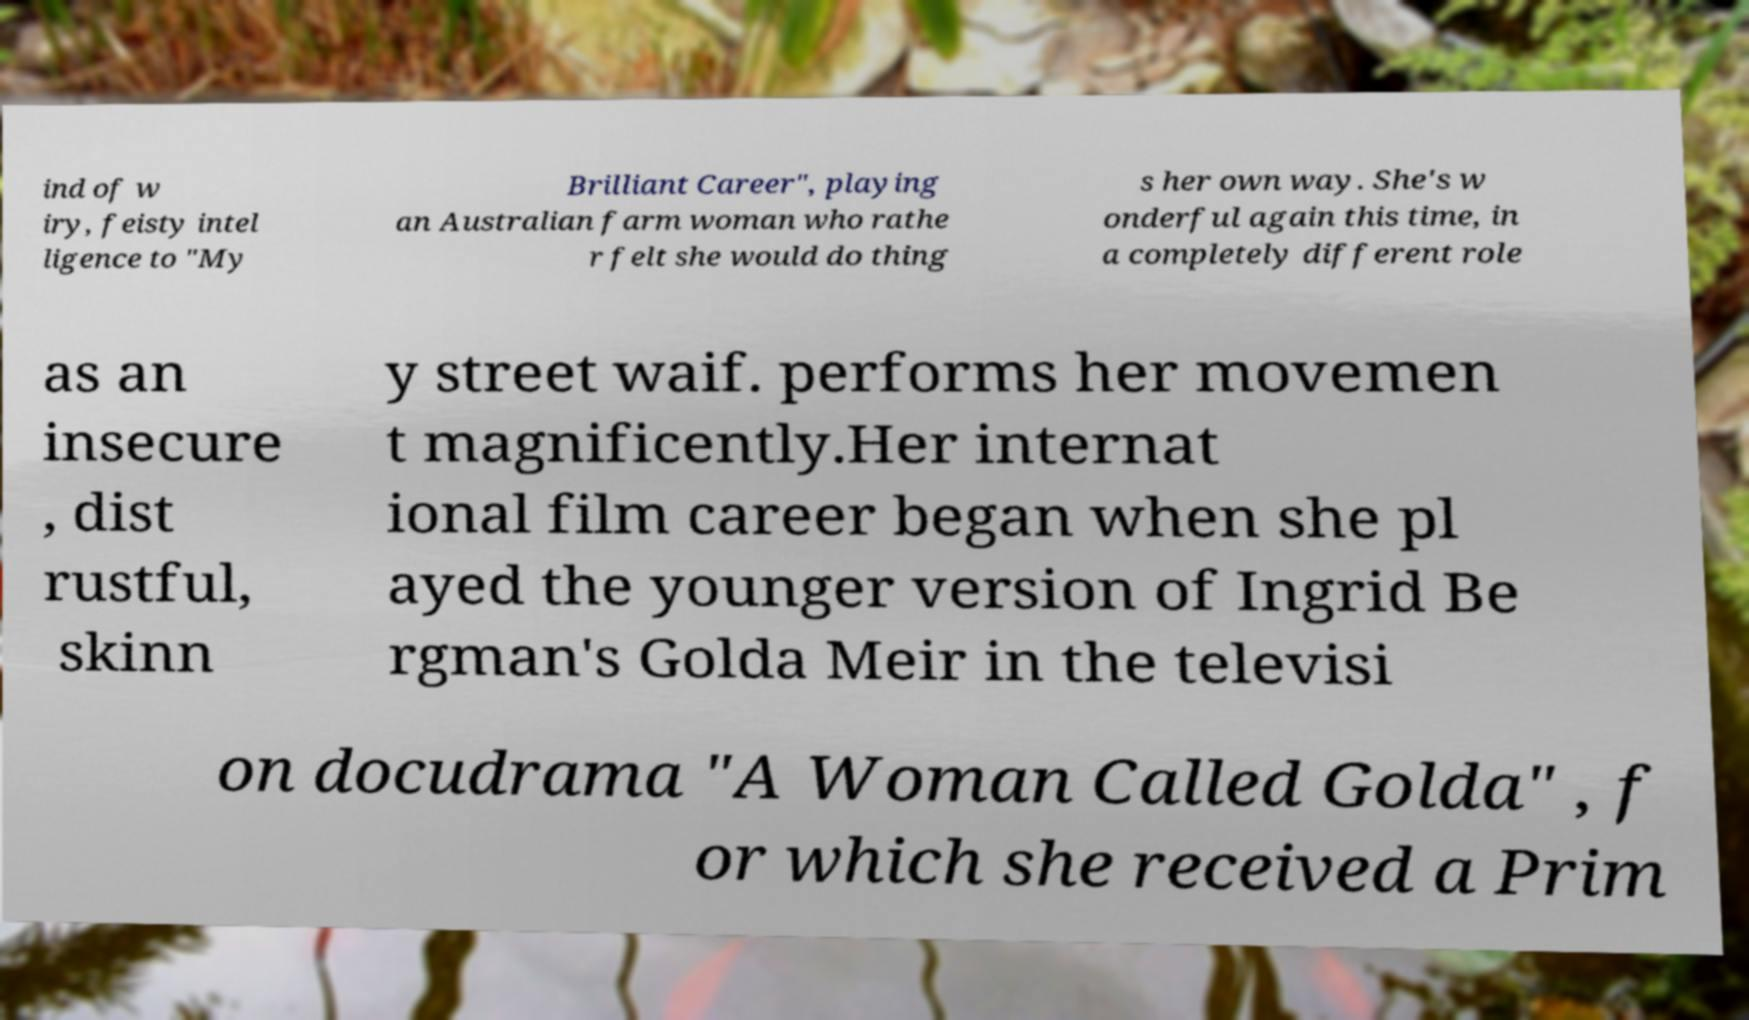I need the written content from this picture converted into text. Can you do that? ind of w iry, feisty intel ligence to "My Brilliant Career", playing an Australian farm woman who rathe r felt she would do thing s her own way. She's w onderful again this time, in a completely different role as an insecure , dist rustful, skinn y street waif. performs her movemen t magnificently.Her internat ional film career began when she pl ayed the younger version of Ingrid Be rgman's Golda Meir in the televisi on docudrama "A Woman Called Golda" , f or which she received a Prim 